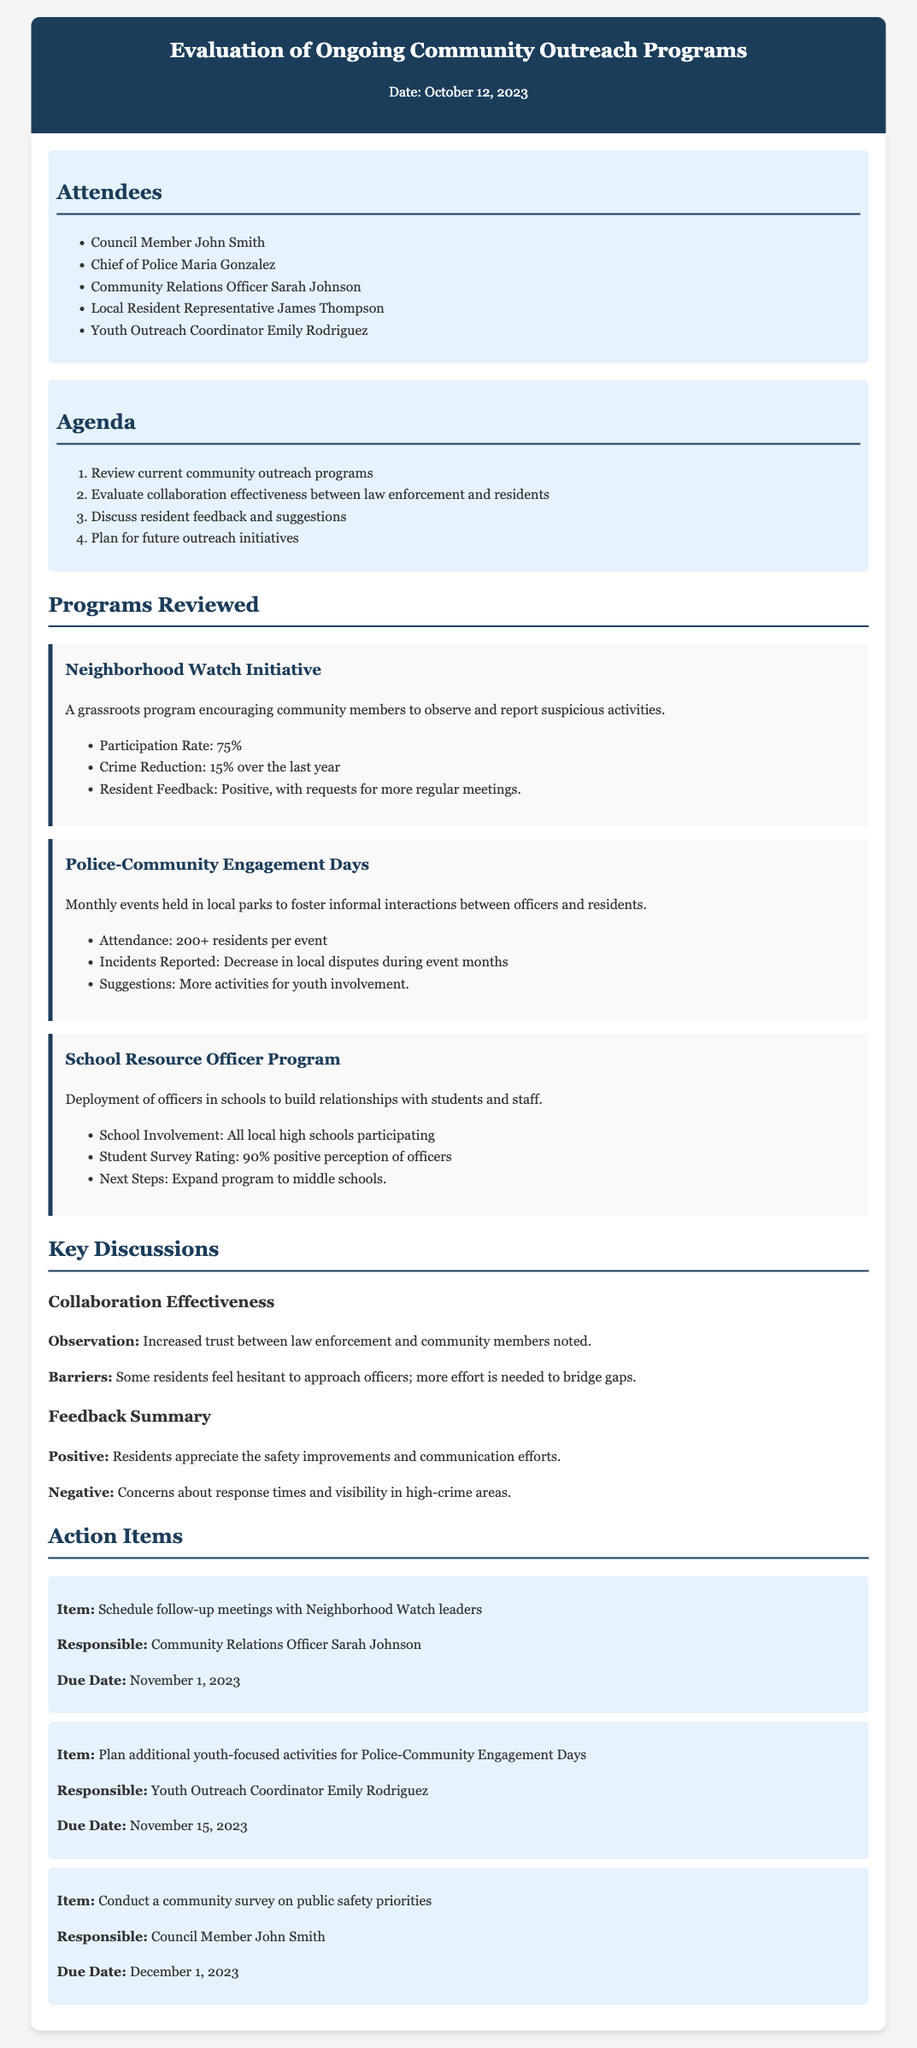What is the date of the meeting? The date of the meeting is stated at the top of the document.
Answer: October 12, 2023 Who is responsible for scheduling follow-up meetings with Neighborhood Watch leaders? This information is found in the action items section specifying the responsible person for each task.
Answer: Sarah Johnson What is the participation rate for the Neighborhood Watch Initiative? The participation rate is provided in the overview of the program.
Answer: 75% How many residents typically attend the Police-Community Engagement Days? This data is included in the description of the program focused on community engagement.
Answer: 200+ What was noted as a barrier in collaboration effectiveness? The discussion section outlines barriers to collaboration, pointing out specific community sentiments.
Answer: Hesitant to approach officers What is the next step for the School Resource Officer Program? The next steps are mentioned in the program review section for future planning.
Answer: Expand program to middle schools What positive feedback did the residents provide? This information is noted in the feedback summary highlighting positives from the community.
Answer: Safety improvements What is scheduled to be due on November 15, 2023? The due date for action items includes specific tasks alongside their due dates.
Answer: Youth-focused activities for Police-Community Engagement Days What is one of the negative feedback concerns from residents? The negative feedback is summarized in the discussion section, focusing on community concerns.
Answer: Response times 